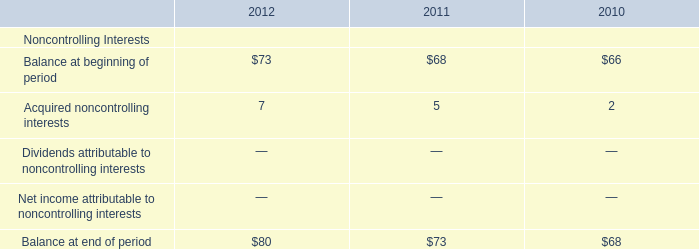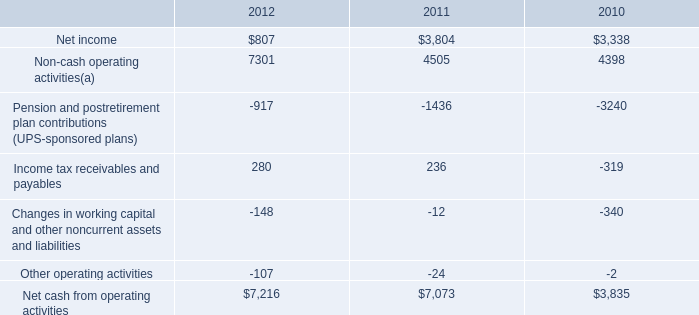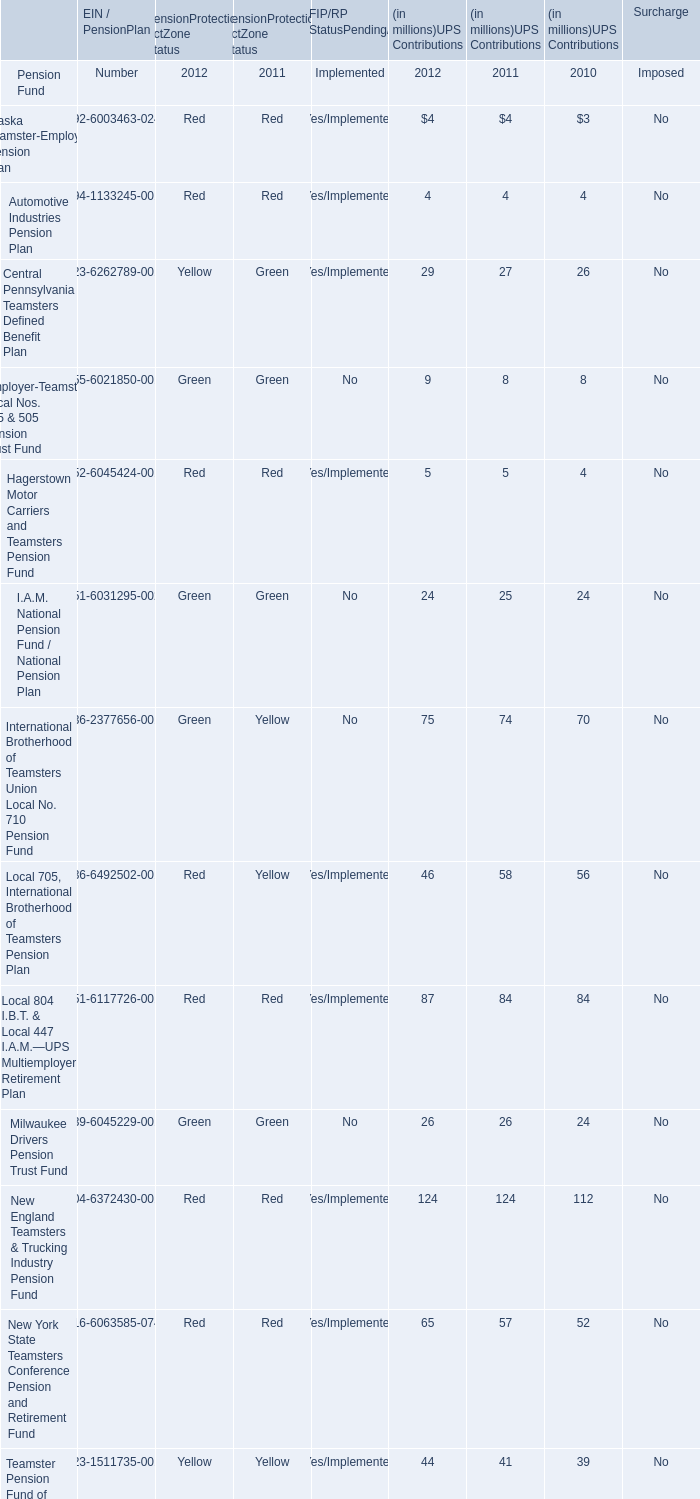what is the percentage change in net cash from operating activities from 2011 to 2012? 
Computations: ((7073 - 7216) / 7216)
Answer: -0.01982. 